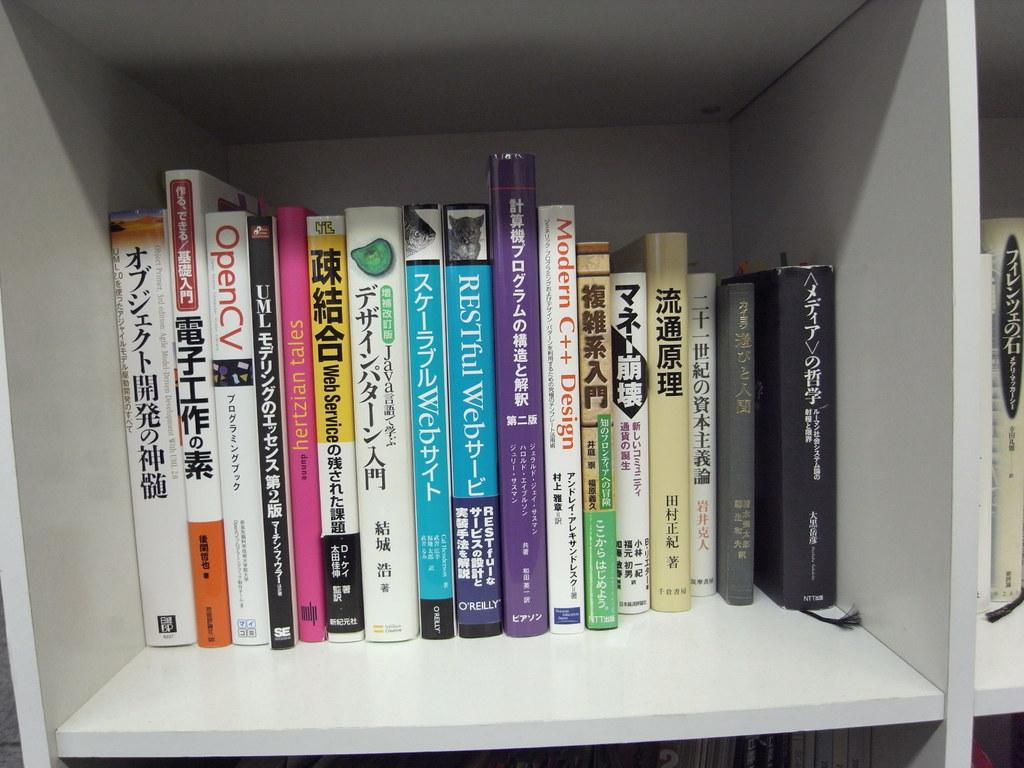<image>
Render a clear and concise summary of the photo. A white, roomy bookcase shelf contains books on OpenCV,  Modern C++ Design, and Web Services. 